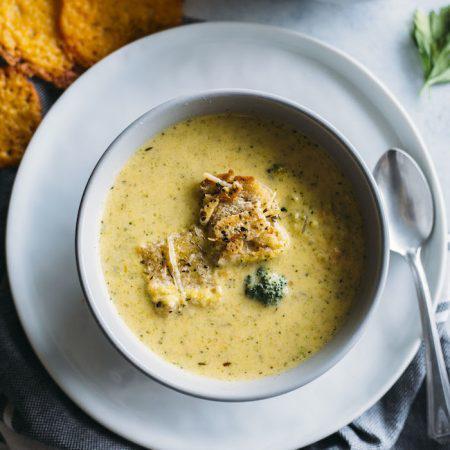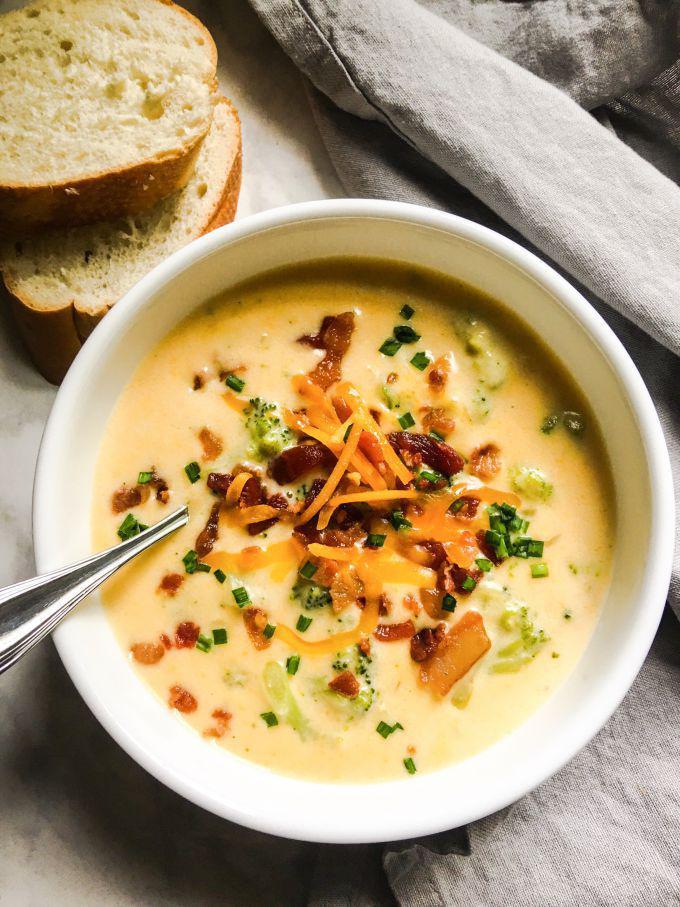The first image is the image on the left, the second image is the image on the right. Examine the images to the left and right. Is the description "Right image shows creamy soup with colorful garnish and bread nearby." accurate? Answer yes or no. Yes. The first image is the image on the left, the second image is the image on the right. Evaluate the accuracy of this statement regarding the images: "there is exactly one bowl with a spoon in it in the image on the right". Is it true? Answer yes or no. Yes. 